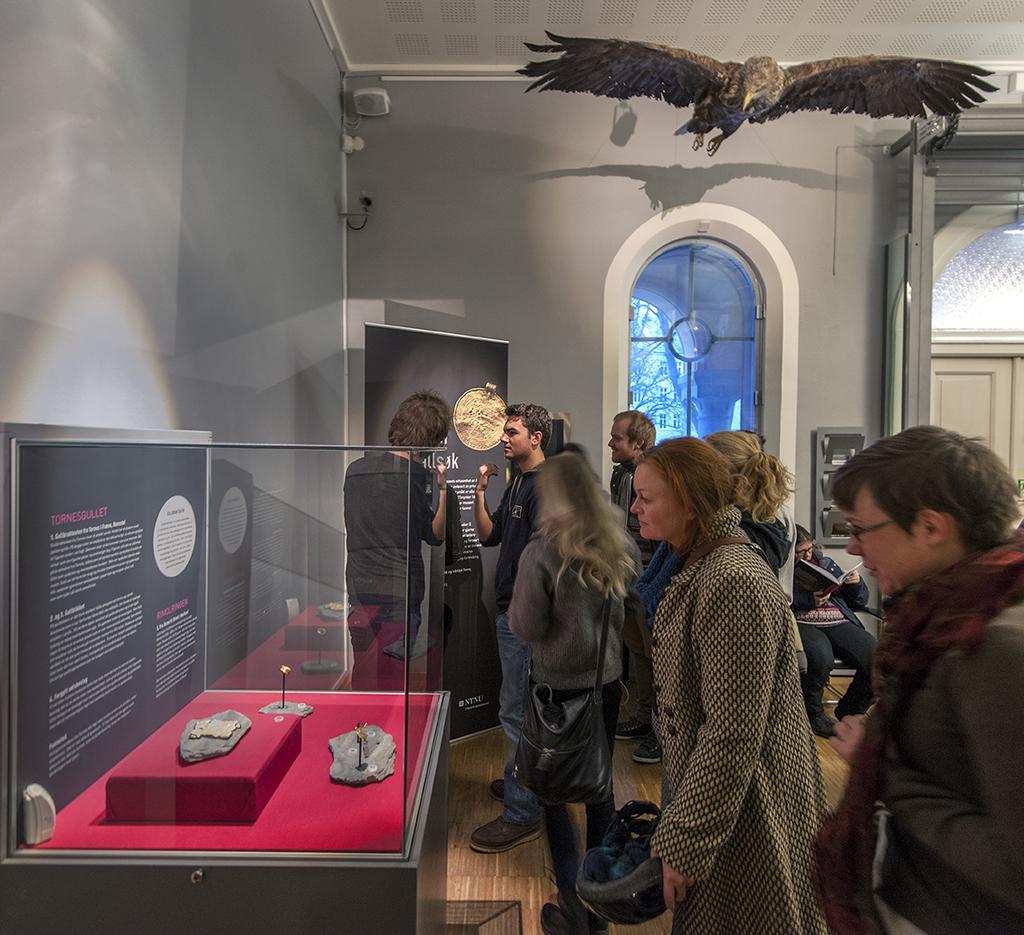In one or two sentences, can you explain what this image depicts? In the image it looks like a museum, there are some antique objects placed inside the glass and there are few people inside the museum and there is a doll of an eagle above the room. 